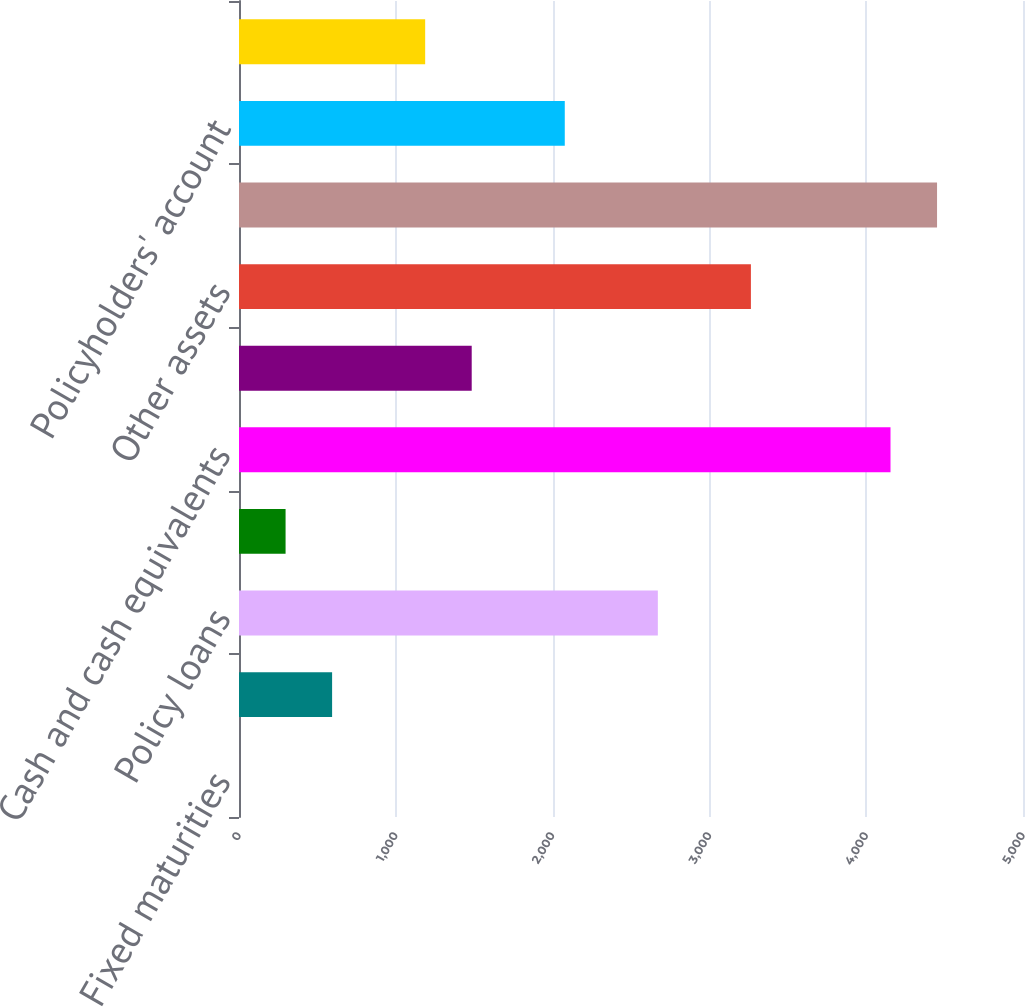Convert chart to OTSL. <chart><loc_0><loc_0><loc_500><loc_500><bar_chart><fcel>Fixed maturities<fcel>Commercial mortgage and other<fcel>Policy loans<fcel>Short-term investments<fcel>Cash and cash equivalents<fcel>Accrued investment income<fcel>Other assets<fcel>Total assets<fcel>Policyholders' account<fcel>Securities sold under<nl><fcel>0.26<fcel>593.8<fcel>2671.19<fcel>297.03<fcel>4155.04<fcel>1484.11<fcel>3264.73<fcel>4451.81<fcel>2077.65<fcel>1187.34<nl></chart> 